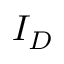Convert formula to latex. <formula><loc_0><loc_0><loc_500><loc_500>I _ { D }</formula> 